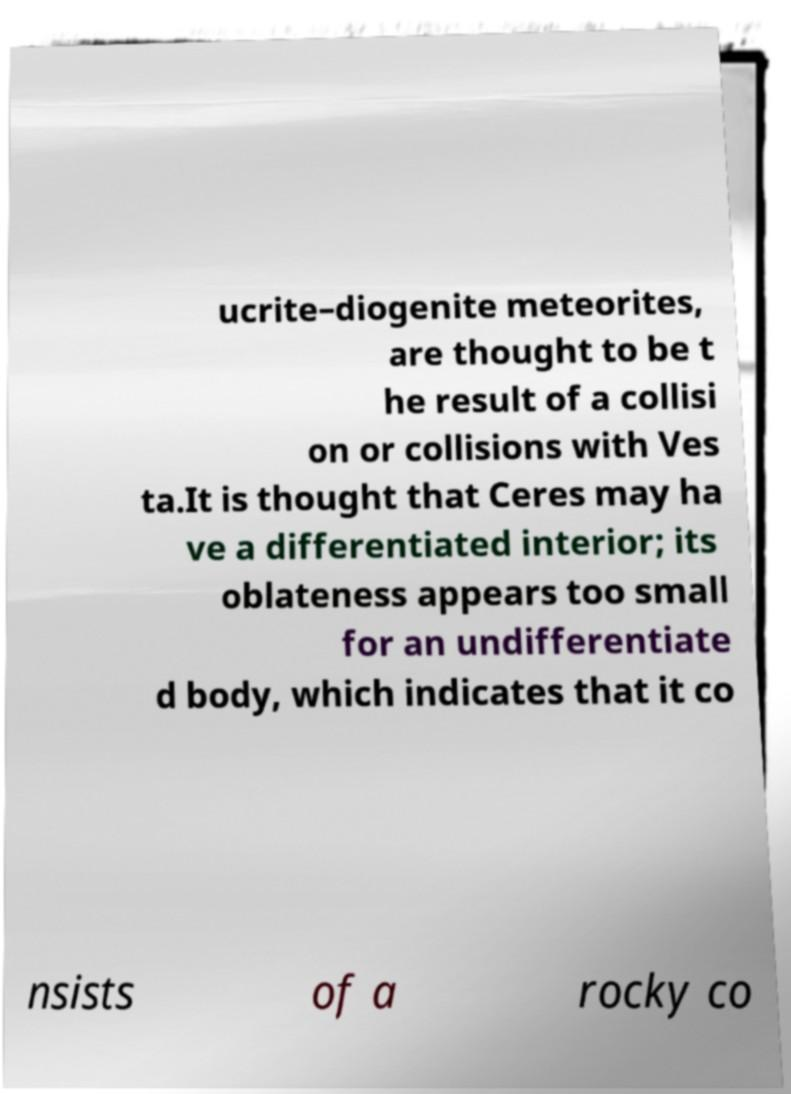There's text embedded in this image that I need extracted. Can you transcribe it verbatim? ucrite–diogenite meteorites, are thought to be t he result of a collisi on or collisions with Ves ta.It is thought that Ceres may ha ve a differentiated interior; its oblateness appears too small for an undifferentiate d body, which indicates that it co nsists of a rocky co 